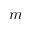Convert formula to latex. <formula><loc_0><loc_0><loc_500><loc_500>m</formula> 